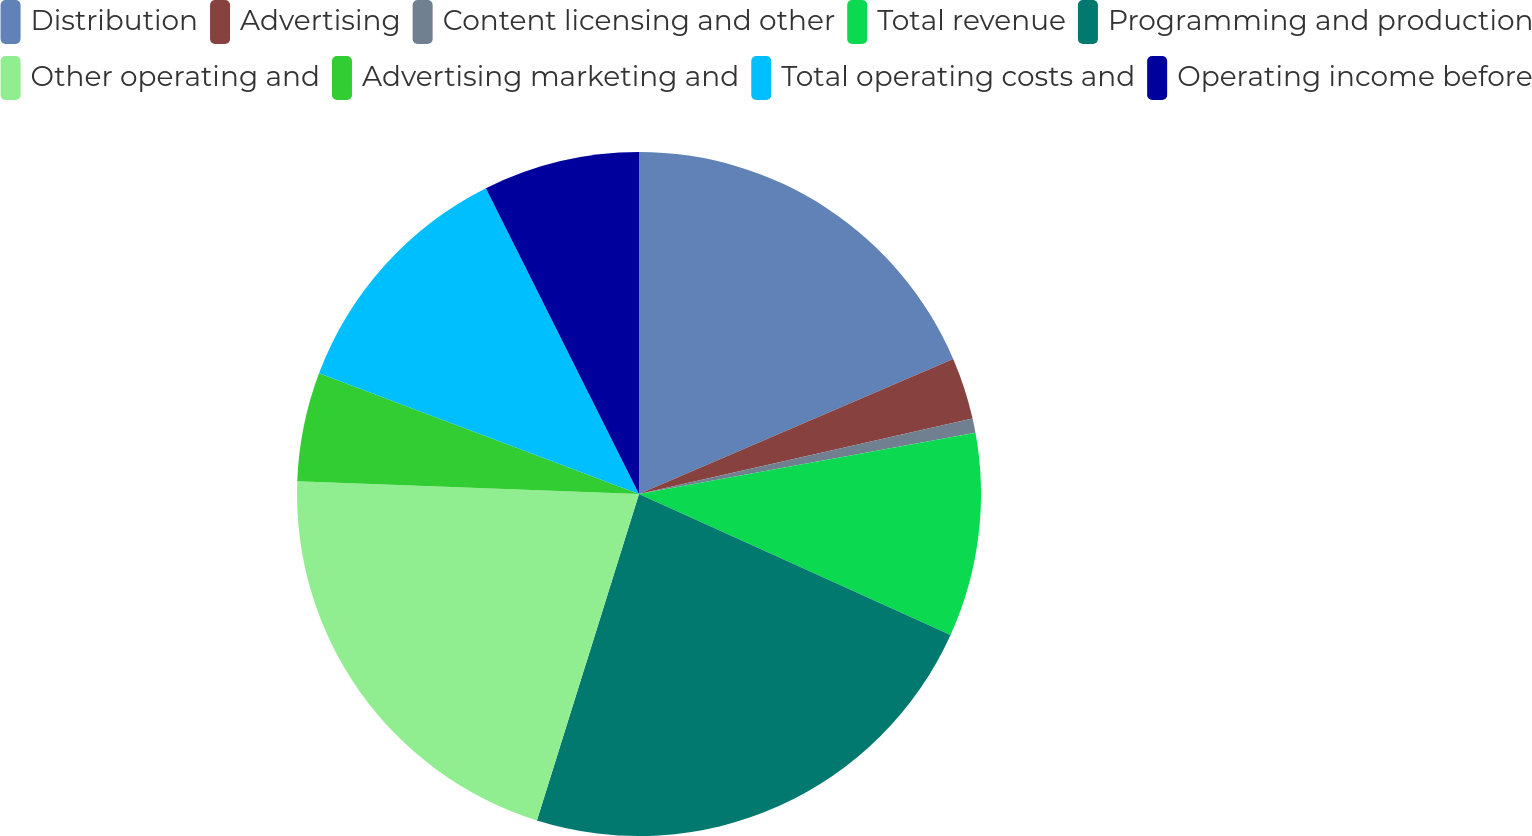<chart> <loc_0><loc_0><loc_500><loc_500><pie_chart><fcel>Distribution<fcel>Advertising<fcel>Content licensing and other<fcel>Total revenue<fcel>Programming and production<fcel>Other operating and<fcel>Advertising marketing and<fcel>Total operating costs and<fcel>Operating income before<nl><fcel>18.54%<fcel>2.92%<fcel>0.68%<fcel>9.63%<fcel>23.06%<fcel>20.77%<fcel>5.15%<fcel>11.87%<fcel>7.39%<nl></chart> 